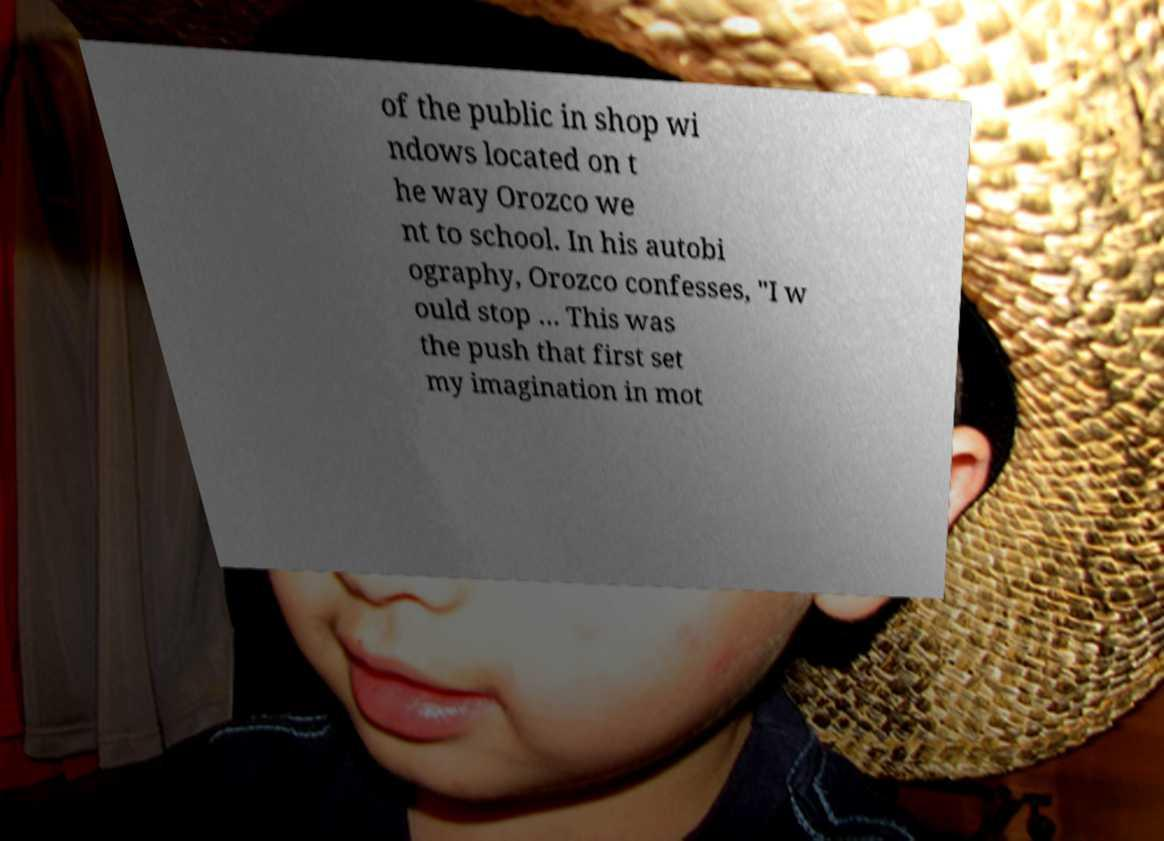There's text embedded in this image that I need extracted. Can you transcribe it verbatim? of the public in shop wi ndows located on t he way Orozco we nt to school. In his autobi ography, Orozco confesses, "I w ould stop … This was the push that first set my imagination in mot 